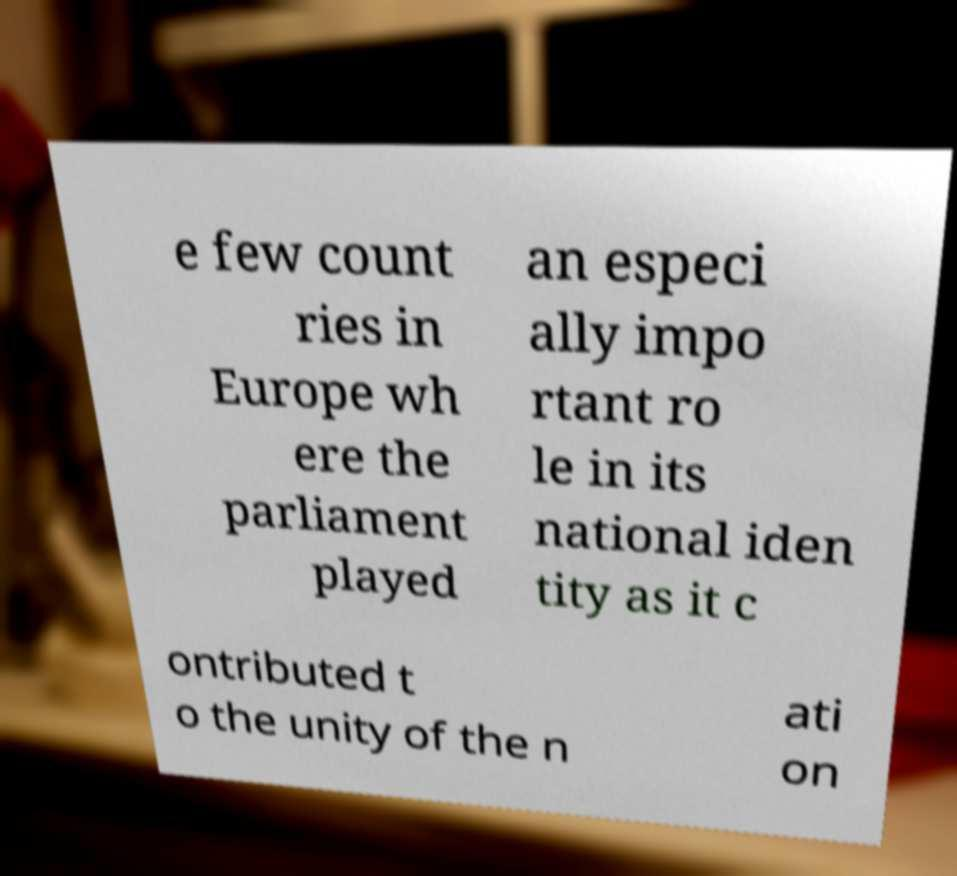Could you assist in decoding the text presented in this image and type it out clearly? e few count ries in Europe wh ere the parliament played an especi ally impo rtant ro le in its national iden tity as it c ontributed t o the unity of the n ati on 